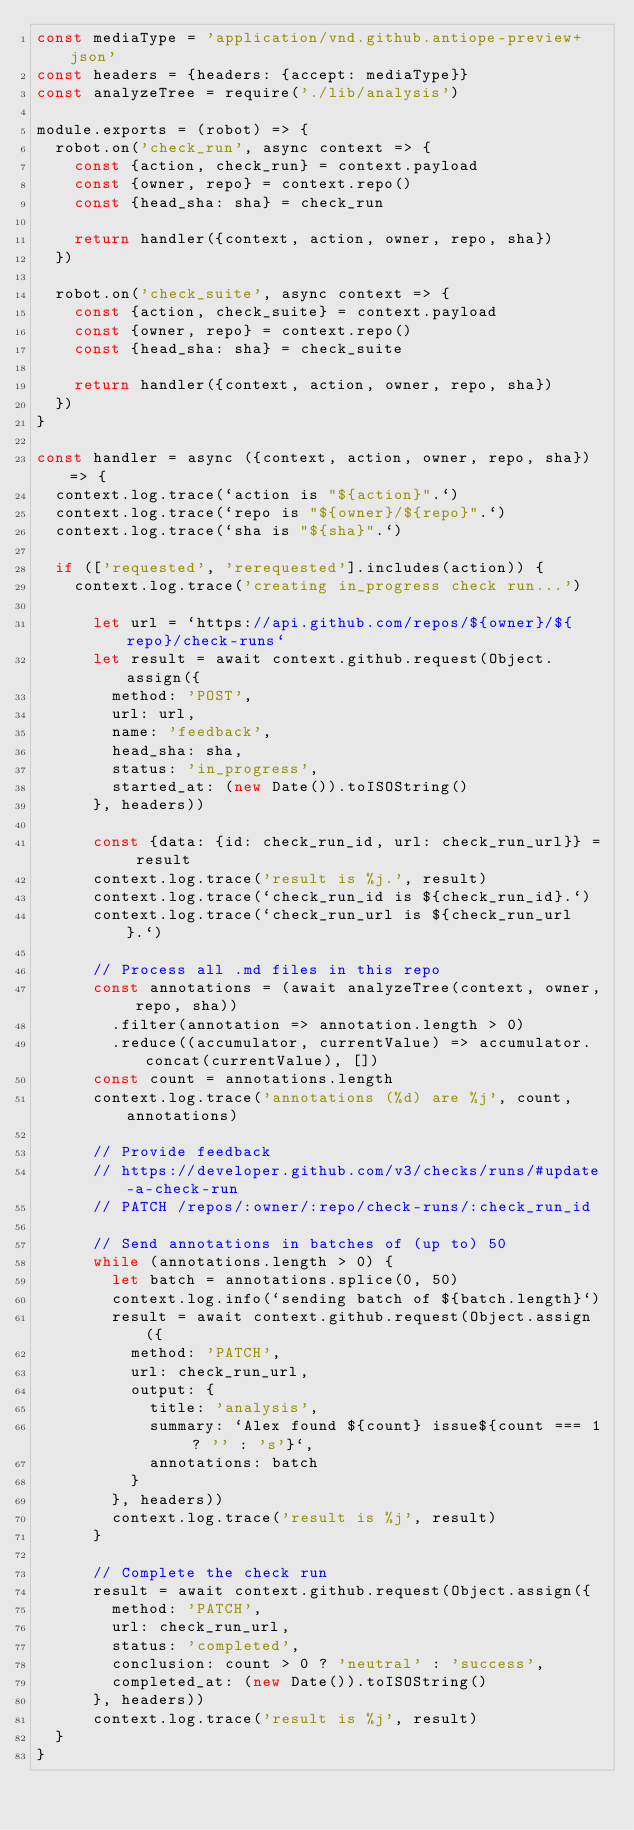<code> <loc_0><loc_0><loc_500><loc_500><_JavaScript_>const mediaType = 'application/vnd.github.antiope-preview+json'
const headers = {headers: {accept: mediaType}}
const analyzeTree = require('./lib/analysis')

module.exports = (robot) => {
  robot.on('check_run', async context => {
    const {action, check_run} = context.payload
    const {owner, repo} = context.repo()
    const {head_sha: sha} = check_run

    return handler({context, action, owner, repo, sha})
  })

  robot.on('check_suite', async context => {
    const {action, check_suite} = context.payload
    const {owner, repo} = context.repo()
    const {head_sha: sha} = check_suite

    return handler({context, action, owner, repo, sha})
  })
}

const handler = async ({context, action, owner, repo, sha}) => {
  context.log.trace(`action is "${action}".`)
  context.log.trace(`repo is "${owner}/${repo}".`)
  context.log.trace(`sha is "${sha}".`)

  if (['requested', 'rerequested'].includes(action)) {
    context.log.trace('creating in_progress check run...')

      let url = `https://api.github.com/repos/${owner}/${repo}/check-runs`
      let result = await context.github.request(Object.assign({
        method: 'POST',
        url: url,
        name: 'feedback',
        head_sha: sha,
        status: 'in_progress',
        started_at: (new Date()).toISOString()
      }, headers))

      const {data: {id: check_run_id, url: check_run_url}} = result
      context.log.trace('result is %j.', result)
      context.log.trace(`check_run_id is ${check_run_id}.`)
      context.log.trace(`check_run_url is ${check_run_url}.`)

      // Process all .md files in this repo
      const annotations = (await analyzeTree(context, owner, repo, sha))
        .filter(annotation => annotation.length > 0)
        .reduce((accumulator, currentValue) => accumulator.concat(currentValue), [])
      const count = annotations.length
      context.log.trace('annotations (%d) are %j', count, annotations)

      // Provide feedback
      // https://developer.github.com/v3/checks/runs/#update-a-check-run
      // PATCH /repos/:owner/:repo/check-runs/:check_run_id

      // Send annotations in batches of (up to) 50
      while (annotations.length > 0) {
        let batch = annotations.splice(0, 50)
        context.log.info(`sending batch of ${batch.length}`)
        result = await context.github.request(Object.assign({
          method: 'PATCH',
          url: check_run_url,
          output: {
            title: 'analysis',
            summary: `Alex found ${count} issue${count === 1 ? '' : 's'}`,
            annotations: batch
          }
        }, headers))
        context.log.trace('result is %j', result)
      }

      // Complete the check run
      result = await context.github.request(Object.assign({
        method: 'PATCH',
        url: check_run_url,
        status: 'completed',
        conclusion: count > 0 ? 'neutral' : 'success',
        completed_at: (new Date()).toISOString()
      }, headers))
      context.log.trace('result is %j', result)
  }
}
</code> 